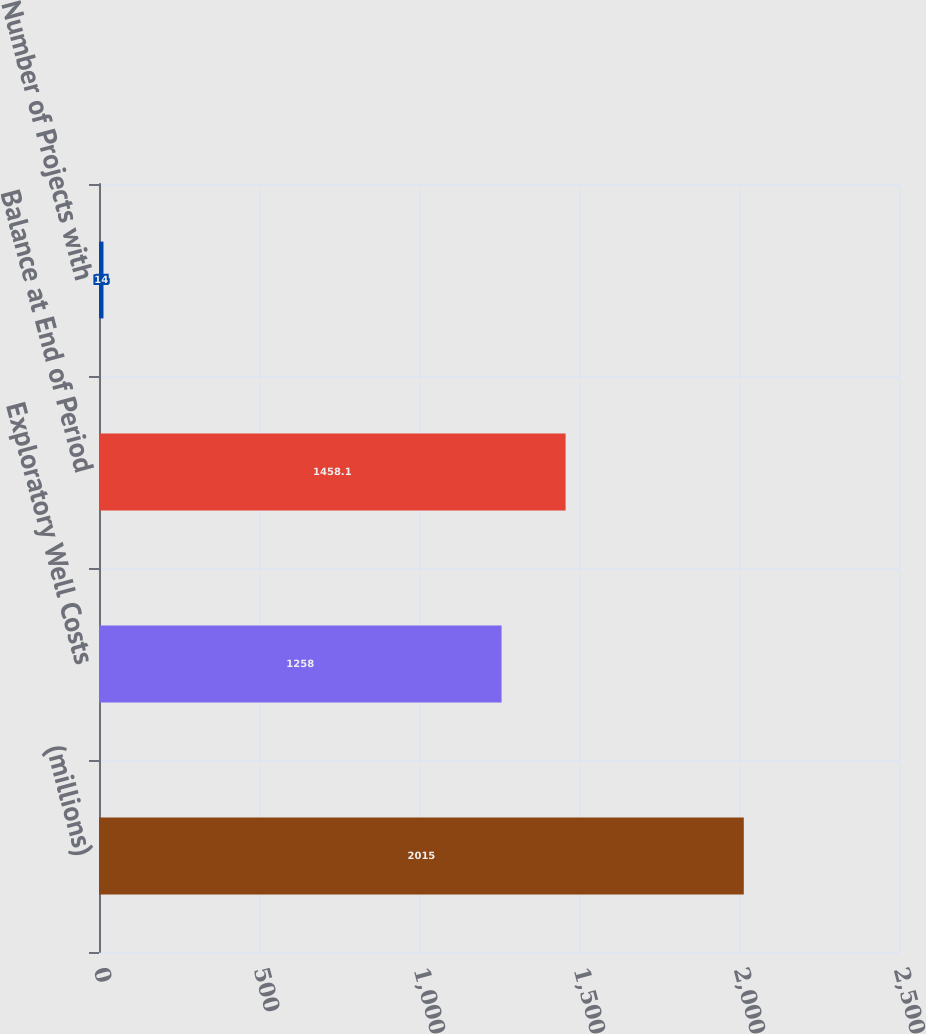<chart> <loc_0><loc_0><loc_500><loc_500><bar_chart><fcel>(millions)<fcel>Exploratory Well Costs<fcel>Balance at End of Period<fcel>Number of Projects with<nl><fcel>2015<fcel>1258<fcel>1458.1<fcel>14<nl></chart> 